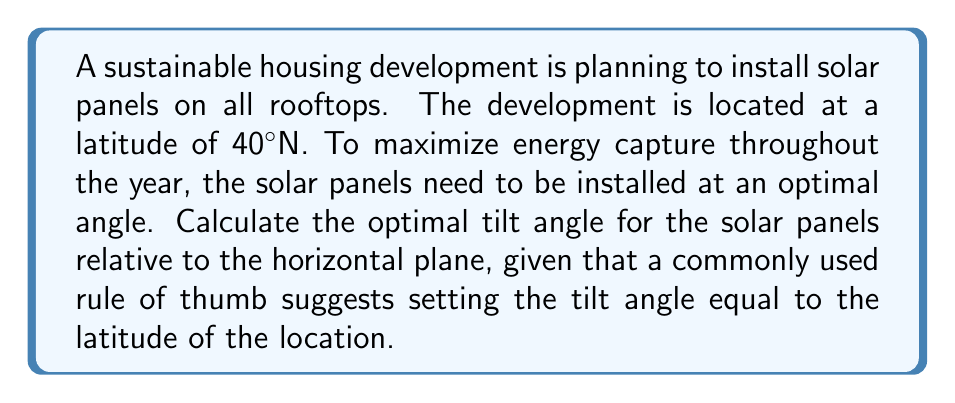Show me your answer to this math problem. To determine the optimal tilt angle for solar panels, we need to consider the following:

1. The rule of thumb for solar panel installation suggests that the optimal tilt angle is approximately equal to the latitude of the location.

2. This rule is based on the idea that the angle helps maximize the amount of direct sunlight the panels receive throughout the year, accounting for the sun's changing position in the sky across seasons.

3. In this case, we are given that the latitude of the location is 40°N.

4. Therefore, the optimal tilt angle can be calculated as follows:

   $$ \text{Optimal Tilt Angle} = \text{Latitude} $$

   $$ \text{Optimal Tilt Angle} = 40° $$

5. It's important to note that this is a general guideline. Factors such as local climate conditions, terrain, and specific energy needs might necessitate slight adjustments to this angle for truly optimal performance.

6. The angle is measured from the horizontal plane, so a 40° tilt would form a 40° angle with the horizontal roof surface, and consequently a 50° angle with the vertical.

[asy]
import geometry;

size(200);
draw((0,0)--(100,0),Arrow);
draw((0,0)--(0,100),Arrow);
draw((0,0)--(100,83.9),Arrow);

label("Horizontal", (50,-10));
label("Vertical", (-10,50));
label("Solar Panel", (70,60));

draw((83.9,83.9)--(100,83.9),dashed);
draw((83.9,83.9)--(83.9,0),dashed);

label("40°", (10,20));
label("50°", (93,70));

dot((0,0));
[/asy]

This optimal angle ensures that the solar panels can capture the maximum amount of solar energy throughout the year, contributing to the sustainable energy goals of the housing development.
Answer: The optimal tilt angle for the solar panels is 40°. 